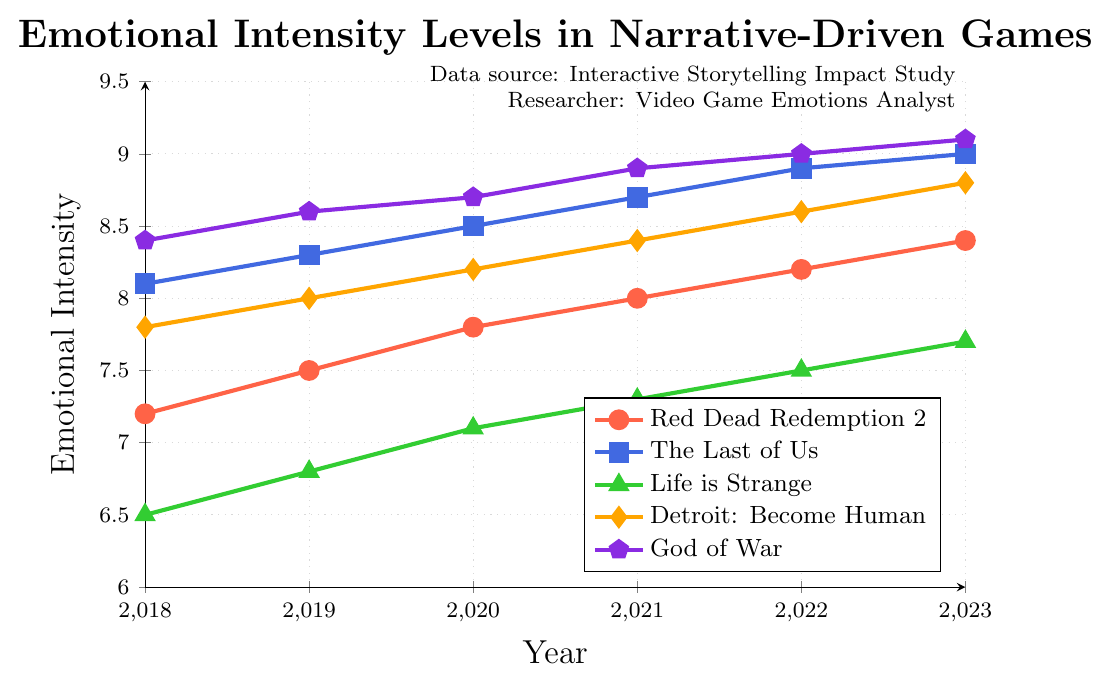What's the trend of emotional intensity levels for "Red Dead Redemption 2" from 2018 to 2023? The plot for "Red Dead Redemption 2" shows a steady increase in emotional intensity from 7.2 in 2018 to 8.4 in 2023. This indicates a gradual upward trend over the six years.
Answer: Gradual upward trend Which game had the highest emotional intensity level in 2023? In 2023, the plot shows that "God of War" had the highest emotional intensity level at 9.1.
Answer: God of War What's the difference in emotional intensity levels between "The Last of Us" and "Life is Strange" in 2020? In 2020, the emotional intensity for "The Last of Us" is 8.5, and for "Life is Strange" it is 7.1. The difference is 8.5 - 7.1 = 1.4.
Answer: 1.4 From 2018 to 2023, which game had the most consistent increase in emotional intensity levels? Observing the plots, "Life is Strange" had a steady rise from 6.5 in 2018 to 7.7 in 2023, indicating a consistent increase without drastic spikes.
Answer: Life is Strange What is the average emotional intensity level for "Detroit: Become Human" from 2018 to 2023? The emotional intensity levels for "Detroit: Become Human" from 2018 to 2023 are 7.8, 8.0, 8.2, 8.4, 8.6, and 8.8. The sum is 49.8, and the average is 49.8 / 6 ≈ 8.3.
Answer: Approximately 8.3 How does the growth in emotional intensity of "The Last of Us" compare to "Red Dead Redemption 2" from 2018 to 2023? "The Last of Us" grows from 8.1 to 9.0, an increase of 0.9 over six years. "Red Dead Redemption 2" grows from 7.2 to 8.4, an increase of 1.2. Hence, "Red Dead Redemption 2" shows a slightly higher absolute increase.
Answer: "Red Dead Redemption 2" shows a higher absolute increase What is the overall trend in emotional intensity levels for "God of War" between 2018 and 2023? The plot for "God of War" shows a consistent increase from 8.4 in 2018 to 9.1 in 2023, indicating a steady upward trend.
Answer: Steady upward trend Which two games have the closest emotional intensity levels in 2023? In 2023, "The Last of Us" has an emotional intensity of 9.0 and "God of War" has 9.1. These two games have the closest emotional intensity levels.
Answer: "The Last of Us" and "God of War" What is the total increase in emotional intensity levels for "Red Dead Redemption 2" from 2018 to 2023? The emotional intensity for "Red Dead Redemption 2" increases from 7.2 in 2018 to 8.4 in 2023. The total increase is 8.4 - 7.2 = 1.2.
Answer: 1.2 